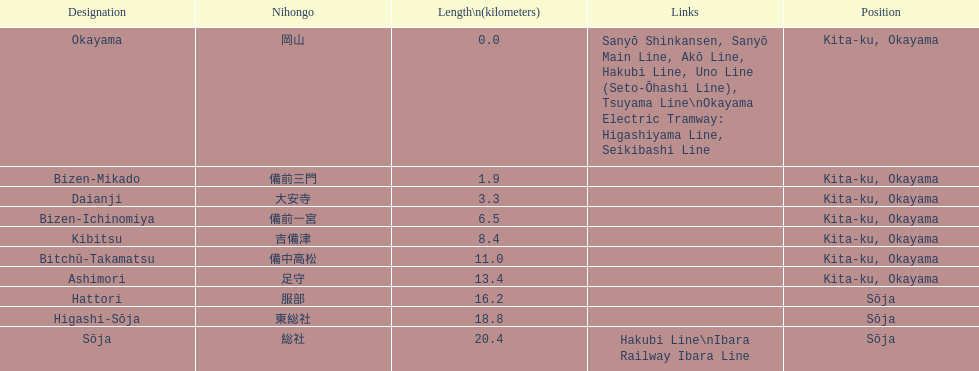How many consecutive stops must you travel through is you board the kibi line at bizen-mikado at depart at kibitsu? 2. 